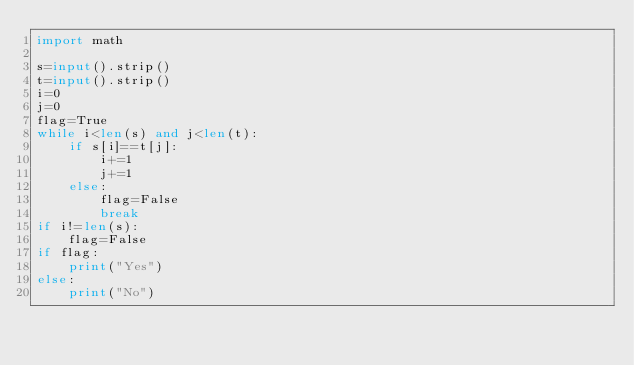Convert code to text. <code><loc_0><loc_0><loc_500><loc_500><_Python_>import math

s=input().strip()
t=input().strip()
i=0
j=0
flag=True
while i<len(s) and j<len(t):
	if s[i]==t[j]:
		i+=1
		j+=1
	else:
		flag=False
		break
if i!=len(s):
	flag=False
if flag:
	print("Yes")
else:
	print("No")</code> 